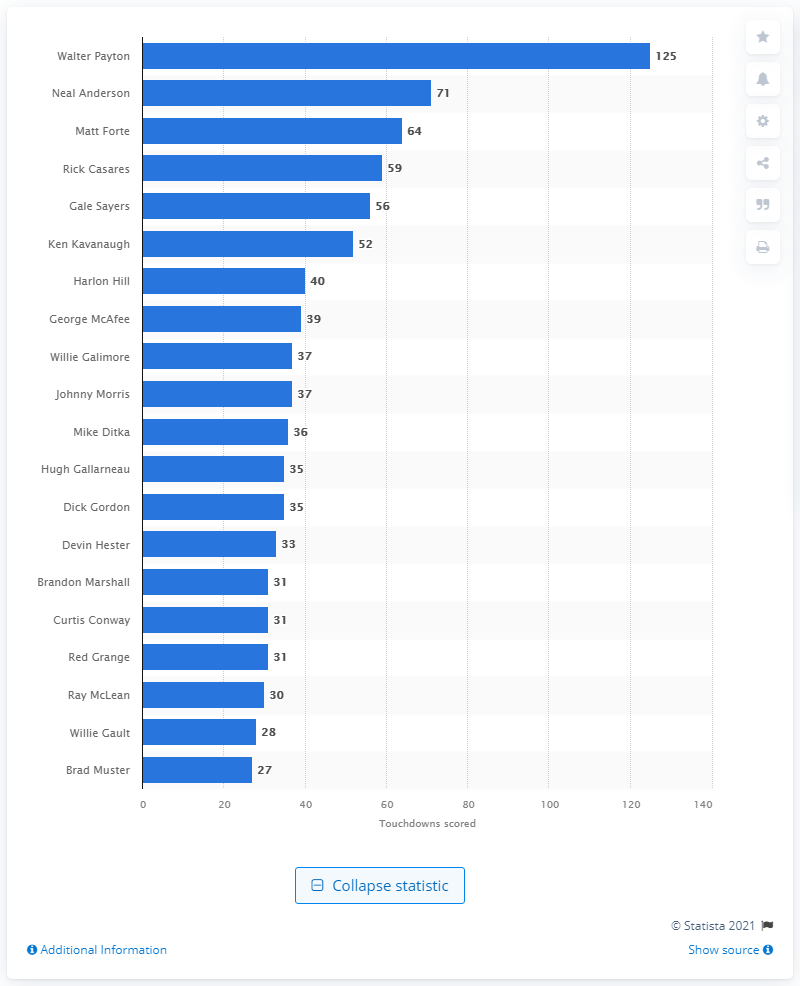Mention a couple of crucial points in this snapshot. Walter Payton is the career touchdown leader of the Chicago Bears. 